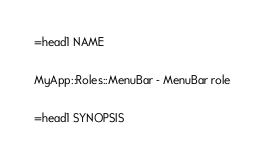Convert code to text. <code><loc_0><loc_0><loc_500><loc_500><_Perl_>
=head1 NAME

MyApp::Roles::MenuBar - MenuBar role

=head1 SYNOPSIS
</code> 